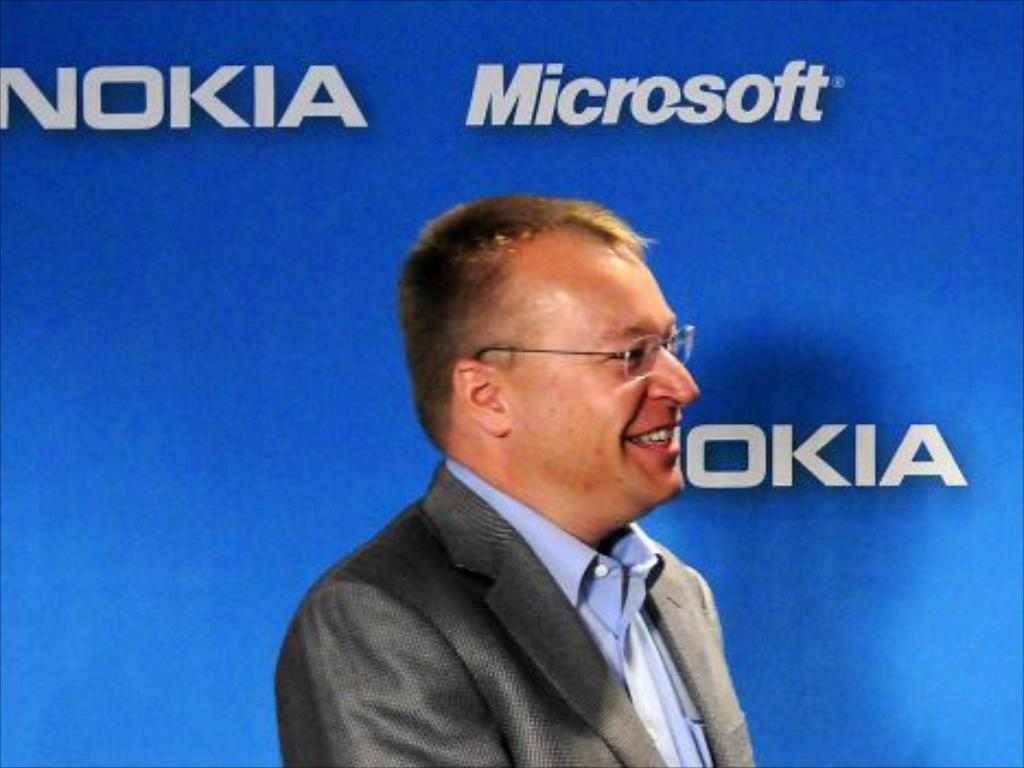<image>
Present a compact description of the photo's key features. a man standing in front of a wall poster that says 'microsoft' 